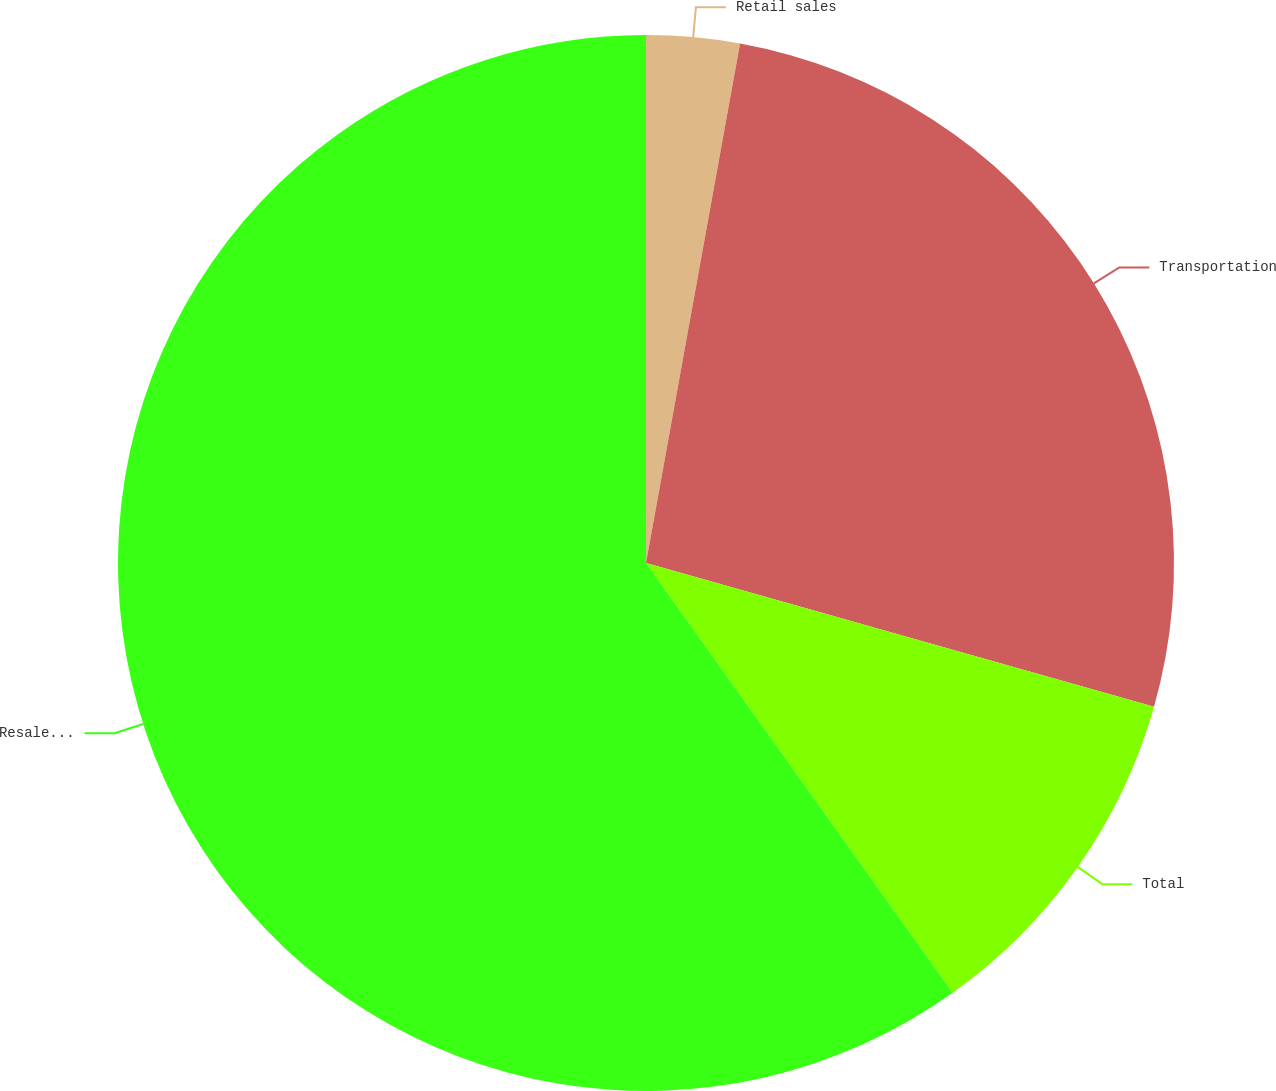<chart> <loc_0><loc_0><loc_500><loc_500><pie_chart><fcel>Retail sales<fcel>Transportation<fcel>Total<fcel>Resale and other<nl><fcel>2.85%<fcel>26.54%<fcel>10.75%<fcel>59.87%<nl></chart> 